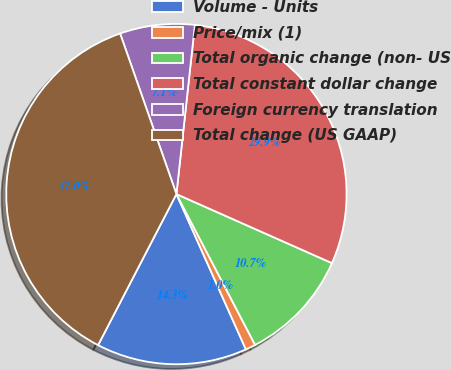<chart> <loc_0><loc_0><loc_500><loc_500><pie_chart><fcel>Volume - Units<fcel>Price/mix (1)<fcel>Total organic change (non- US<fcel>Total constant dollar change<fcel>Foreign currency translation<fcel>Total change (US GAAP)<nl><fcel>14.31%<fcel>0.96%<fcel>10.7%<fcel>29.92%<fcel>7.1%<fcel>37.02%<nl></chart> 